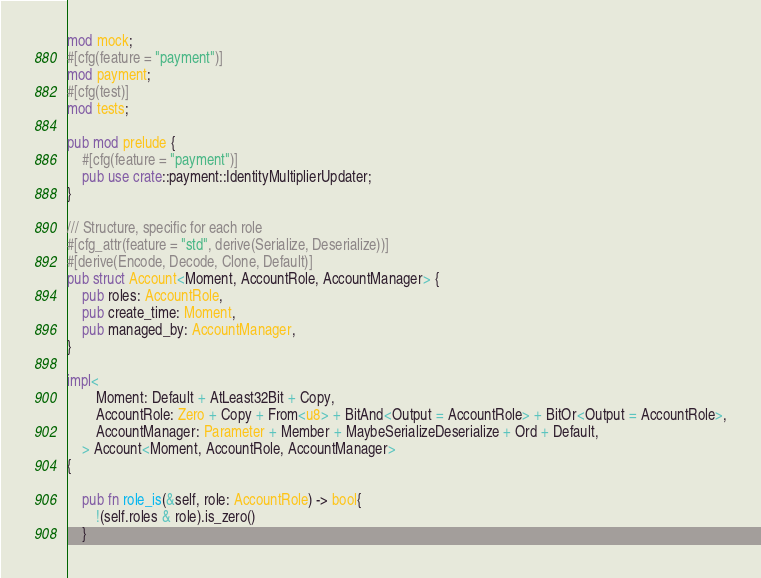<code> <loc_0><loc_0><loc_500><loc_500><_Rust_>mod mock;
#[cfg(feature = "payment")]
mod payment;
#[cfg(test)]
mod tests;

pub mod prelude {
    #[cfg(feature = "payment")]
    pub use crate::payment::IdentityMultiplierUpdater;
}

/// Structure, specific for each role
#[cfg_attr(feature = "std", derive(Serialize, Deserialize))]
#[derive(Encode, Decode, Clone, Default)]
pub struct Account<Moment, AccountRole, AccountManager> {
    pub roles: AccountRole,
    pub create_time: Moment,
    pub managed_by: AccountManager, 
}

impl<
        Moment: Default + AtLeast32Bit + Copy,
        AccountRole: Zero + Copy + From<u8> + BitAnd<Output = AccountRole> + BitOr<Output = AccountRole>,
        AccountManager: Parameter + Member + MaybeSerializeDeserialize + Ord + Default,
    > Account<Moment, AccountRole, AccountManager>
{

    pub fn role_is(&self, role: AccountRole) -> bool{
        !(self.roles & role).is_zero()
    }
</code> 